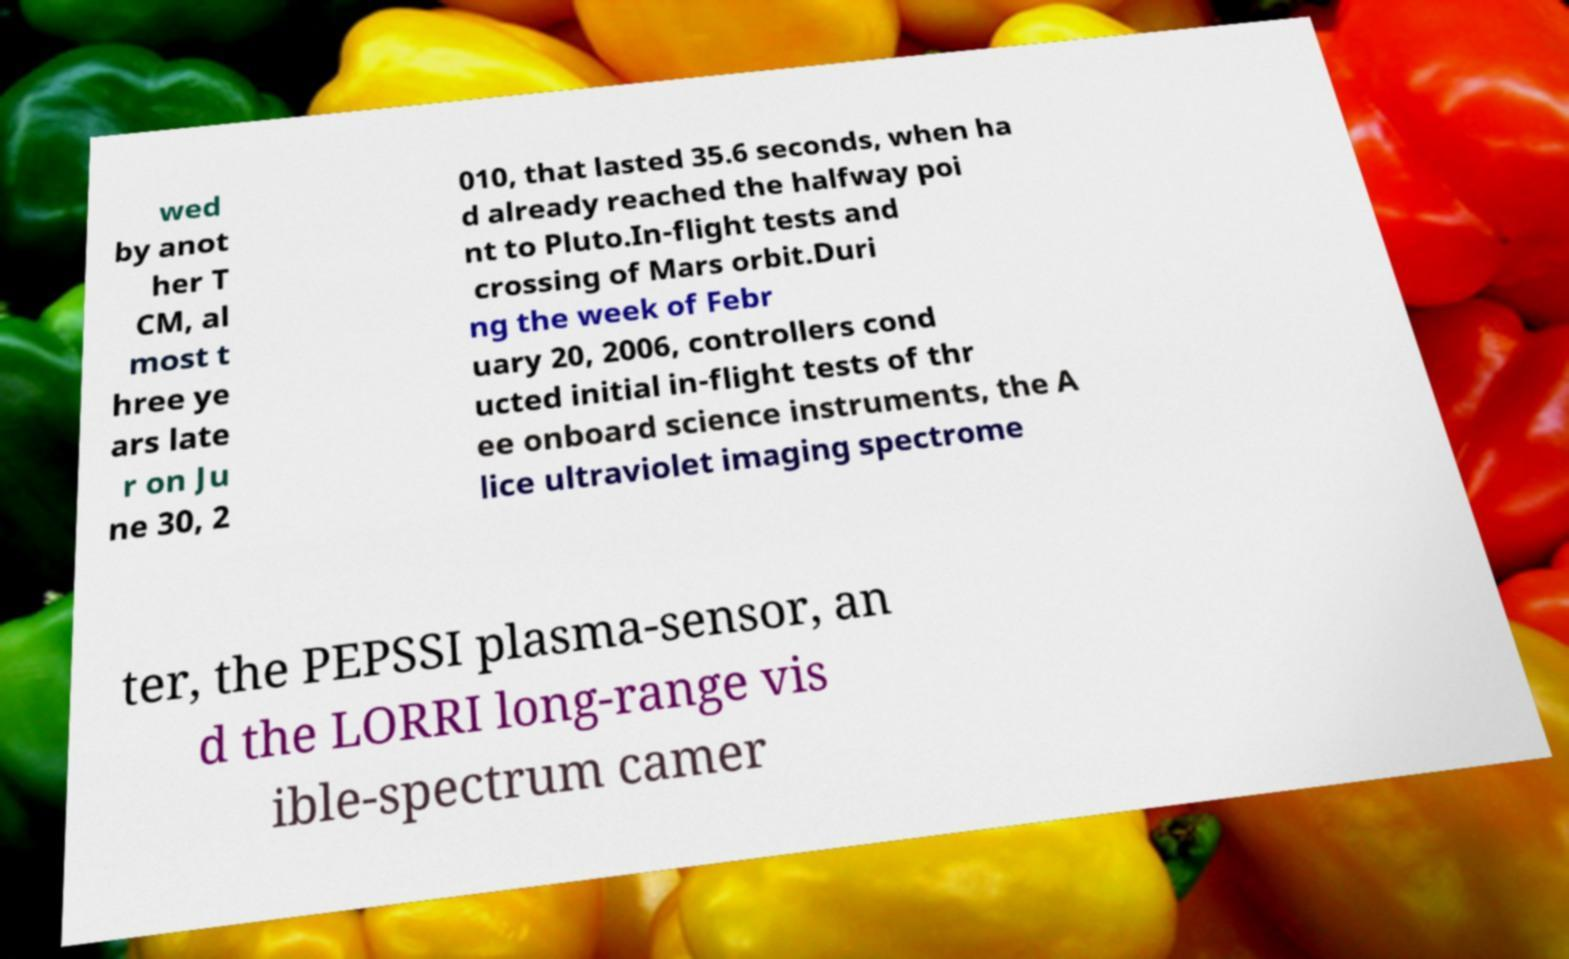I need the written content from this picture converted into text. Can you do that? wed by anot her T CM, al most t hree ye ars late r on Ju ne 30, 2 010, that lasted 35.6 seconds, when ha d already reached the halfway poi nt to Pluto.In-flight tests and crossing of Mars orbit.Duri ng the week of Febr uary 20, 2006, controllers cond ucted initial in-flight tests of thr ee onboard science instruments, the A lice ultraviolet imaging spectrome ter, the PEPSSI plasma-sensor, an d the LORRI long-range vis ible-spectrum camer 